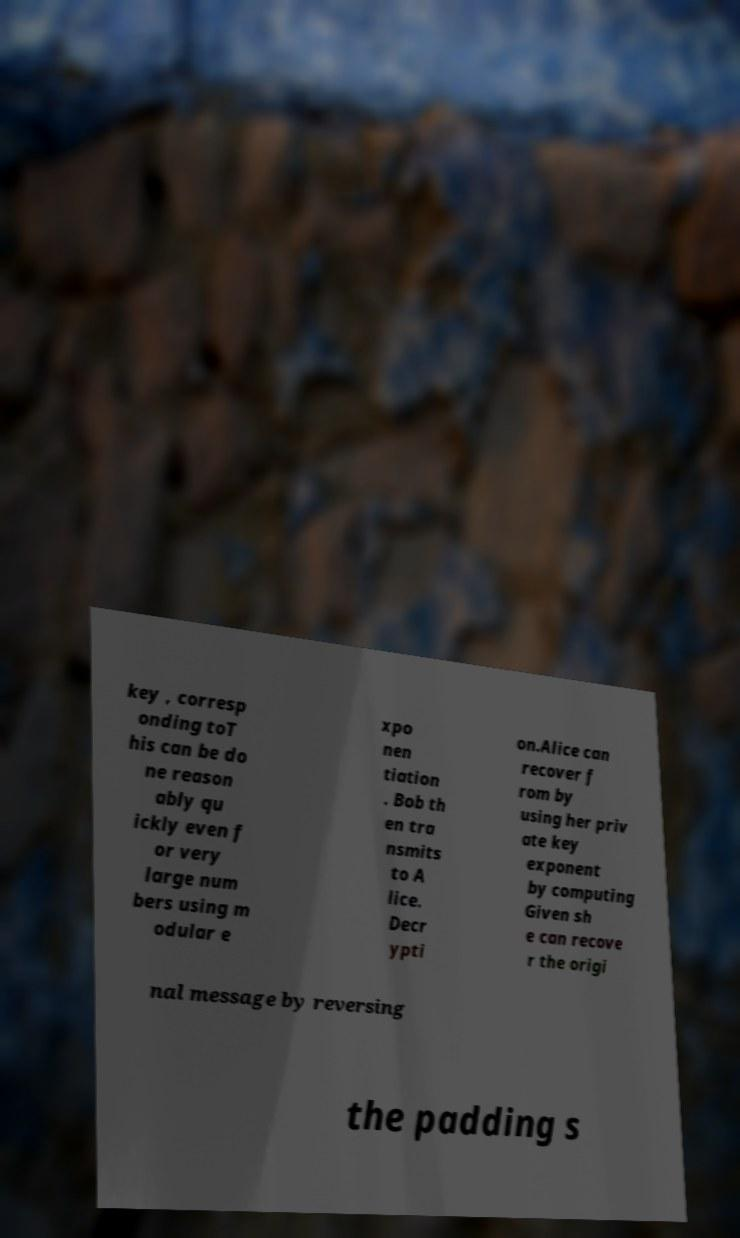Please identify and transcribe the text found in this image. key , corresp onding toT his can be do ne reason ably qu ickly even f or very large num bers using m odular e xpo nen tiation . Bob th en tra nsmits to A lice. Decr ypti on.Alice can recover f rom by using her priv ate key exponent by computing Given sh e can recove r the origi nal message by reversing the padding s 